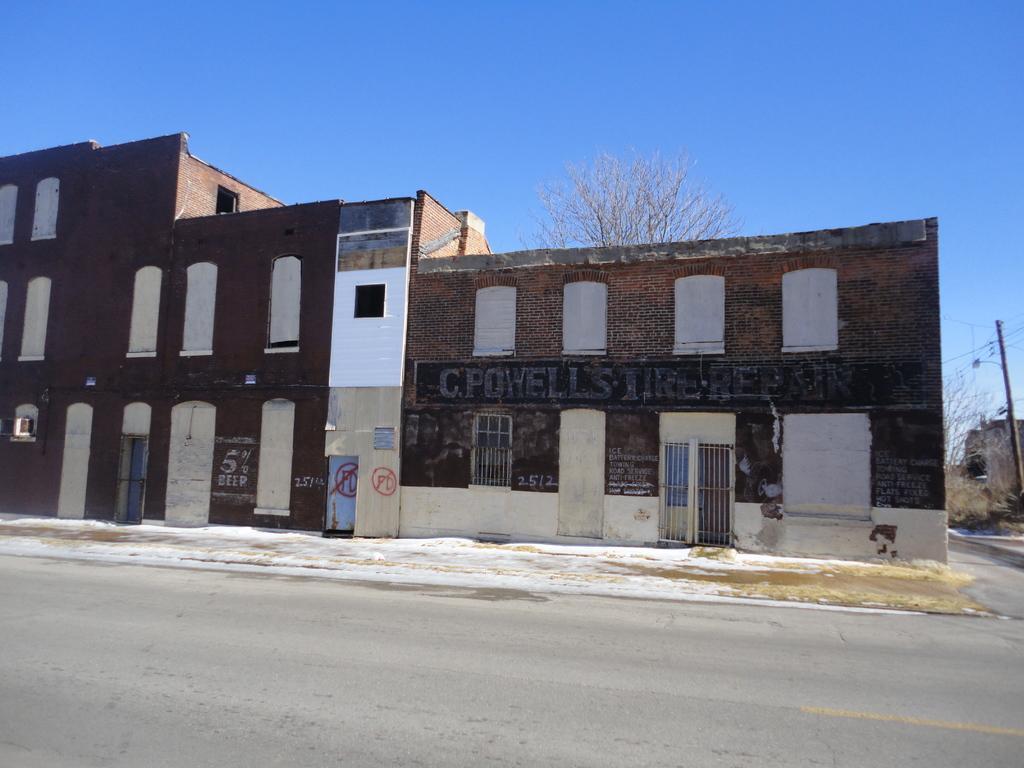Describe this image in one or two sentences. In this image there are buildings. At the bottom there is a road. On the right there is a pole. In the background there are trees and sky. 